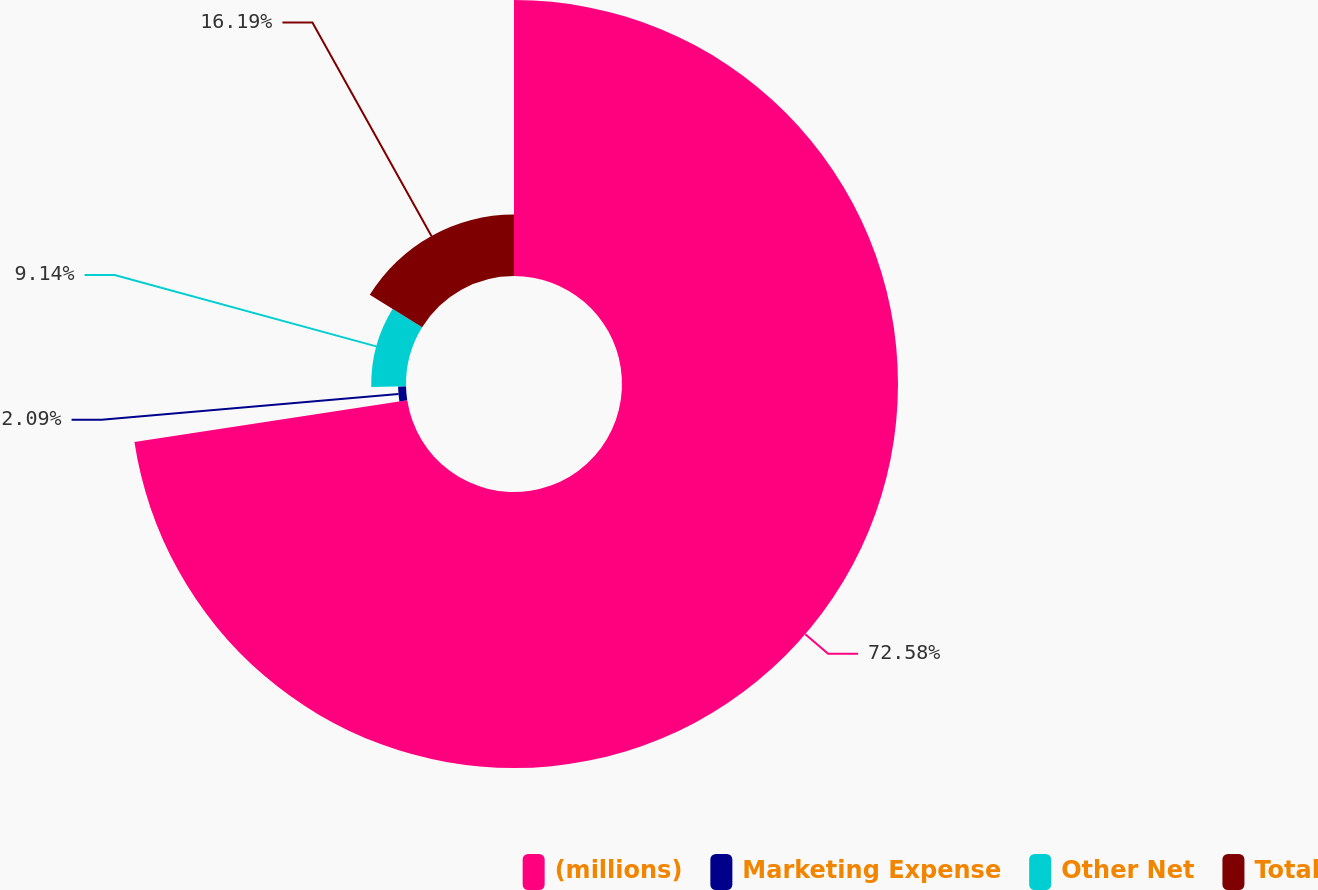<chart> <loc_0><loc_0><loc_500><loc_500><pie_chart><fcel>(millions)<fcel>Marketing Expense<fcel>Other Net<fcel>Total<nl><fcel>72.59%<fcel>2.09%<fcel>9.14%<fcel>16.19%<nl></chart> 